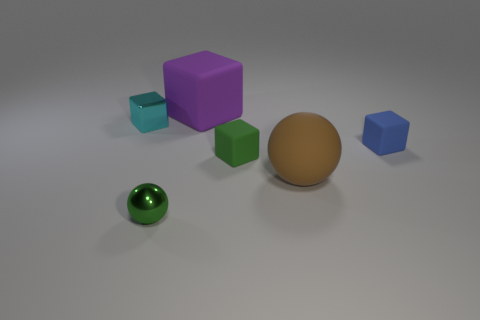Subtract all gray cubes. Subtract all gray balls. How many cubes are left? 4 Add 3 gray metallic balls. How many objects exist? 9 Subtract all blocks. How many objects are left? 2 Add 5 large matte blocks. How many large matte blocks are left? 6 Add 2 shiny spheres. How many shiny spheres exist? 3 Subtract 0 cyan cylinders. How many objects are left? 6 Subtract all large brown metallic spheres. Subtract all metallic spheres. How many objects are left? 5 